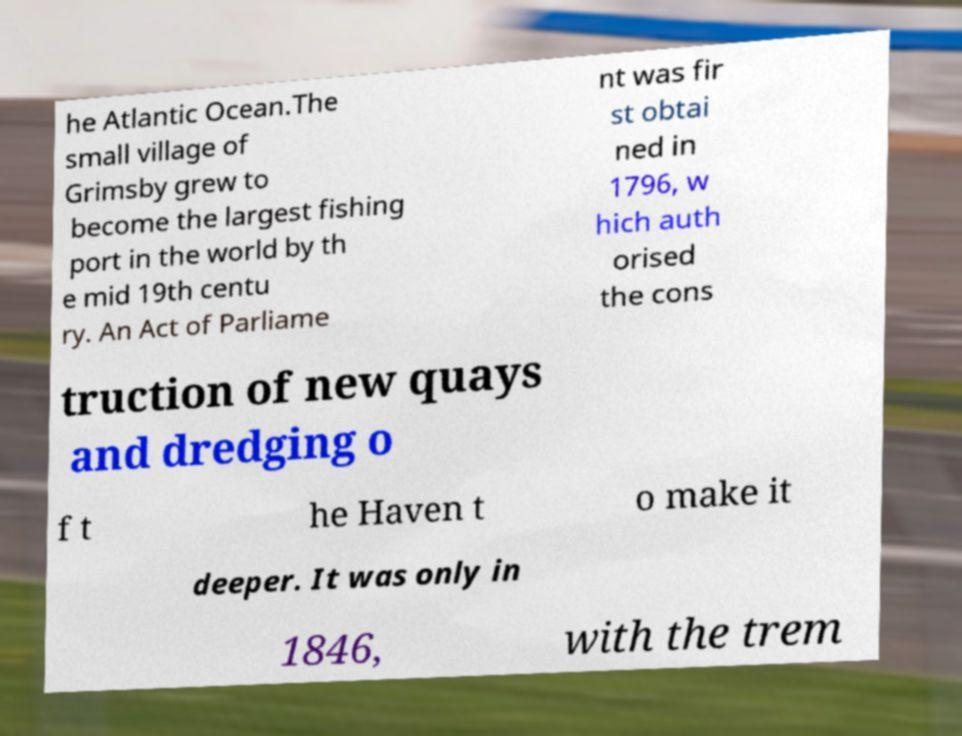Could you extract and type out the text from this image? he Atlantic Ocean.The small village of Grimsby grew to become the largest fishing port in the world by th e mid 19th centu ry. An Act of Parliame nt was fir st obtai ned in 1796, w hich auth orised the cons truction of new quays and dredging o f t he Haven t o make it deeper. It was only in 1846, with the trem 